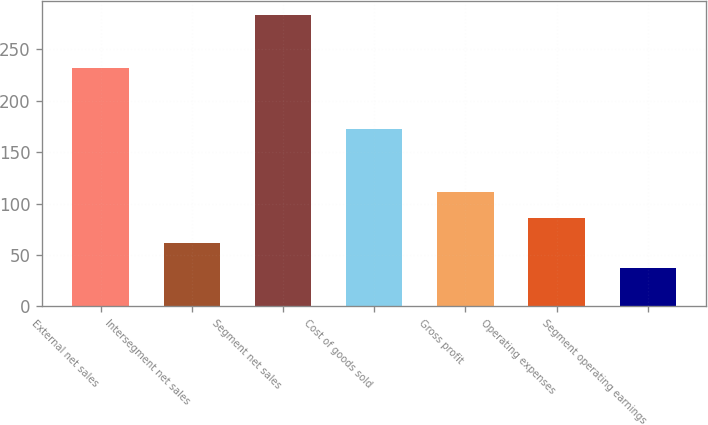Convert chart. <chart><loc_0><loc_0><loc_500><loc_500><bar_chart><fcel>External net sales<fcel>Intersegment net sales<fcel>Segment net sales<fcel>Cost of goods sold<fcel>Gross profit<fcel>Operating expenses<fcel>Segment operating earnings<nl><fcel>231.6<fcel>61.71<fcel>283.2<fcel>172.9<fcel>110.93<fcel>86.32<fcel>37.1<nl></chart> 